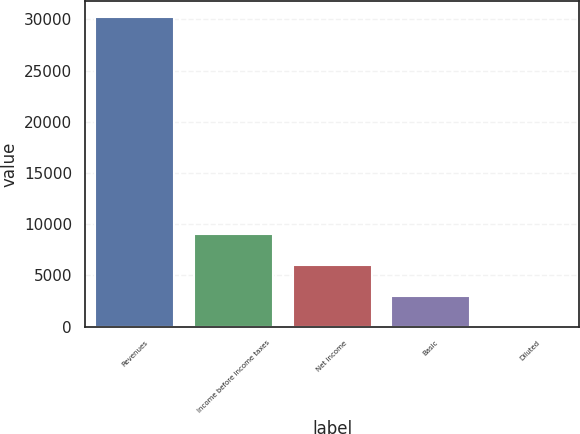Convert chart. <chart><loc_0><loc_0><loc_500><loc_500><bar_chart><fcel>Revenues<fcel>Income before income taxes<fcel>Net income<fcel>Basic<fcel>Diluted<nl><fcel>30247<fcel>9074.39<fcel>6049.73<fcel>3025.07<fcel>0.41<nl></chart> 